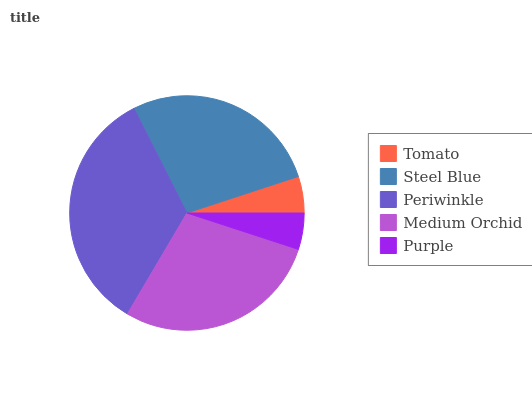Is Purple the minimum?
Answer yes or no. Yes. Is Periwinkle the maximum?
Answer yes or no. Yes. Is Steel Blue the minimum?
Answer yes or no. No. Is Steel Blue the maximum?
Answer yes or no. No. Is Steel Blue greater than Tomato?
Answer yes or no. Yes. Is Tomato less than Steel Blue?
Answer yes or no. Yes. Is Tomato greater than Steel Blue?
Answer yes or no. No. Is Steel Blue less than Tomato?
Answer yes or no. No. Is Steel Blue the high median?
Answer yes or no. Yes. Is Steel Blue the low median?
Answer yes or no. Yes. Is Purple the high median?
Answer yes or no. No. Is Purple the low median?
Answer yes or no. No. 